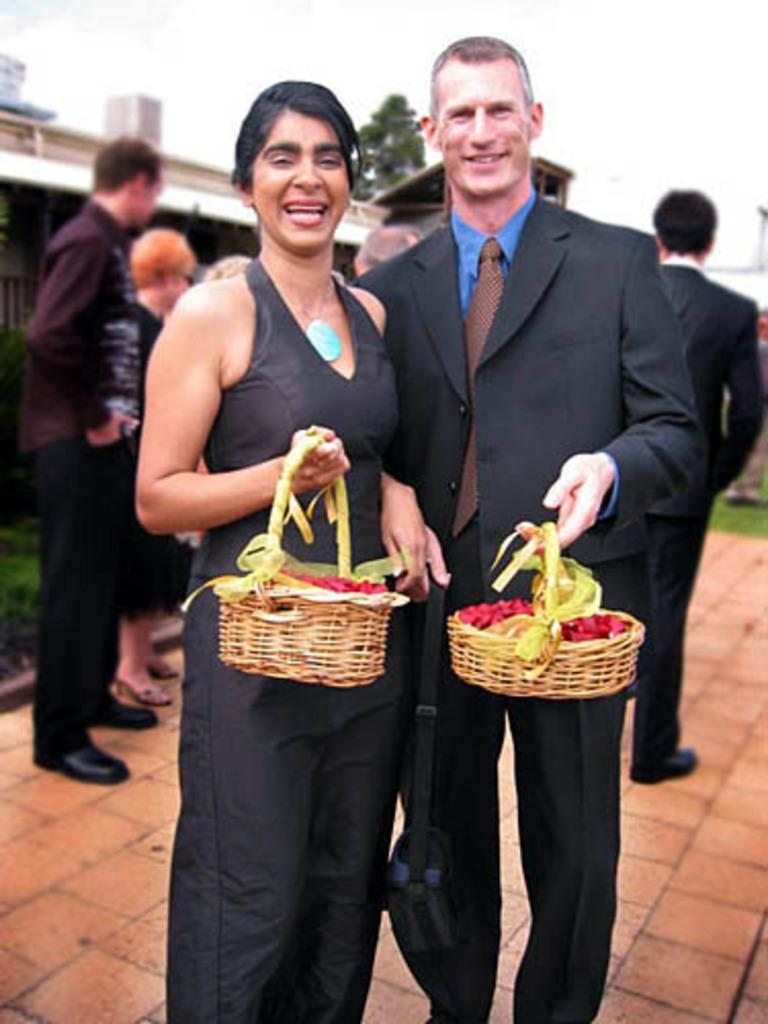How many people are standing in the image? There are 2 people standing in the image. What are the people holding in their hands? The people are holding baskets in their hands. Can you describe the background of the image? There is a tree and buildings in the background of the image, as well as the sky visible at the top. Are there any other people visible in the image besides the two standing? Yes, there are other people visible in the image. What type of error can be seen in the image? There is no error present in the image; it is a clear and accurate representation of the scene. 